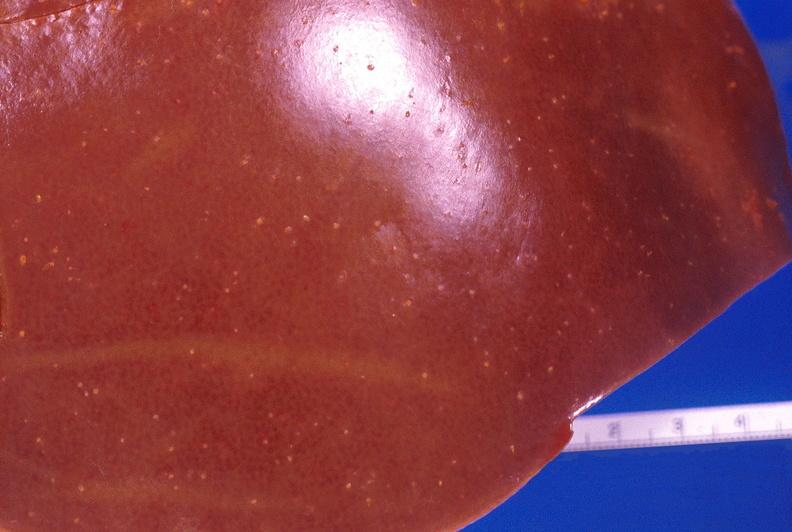s spina bifida present?
Answer the question using a single word or phrase. No 